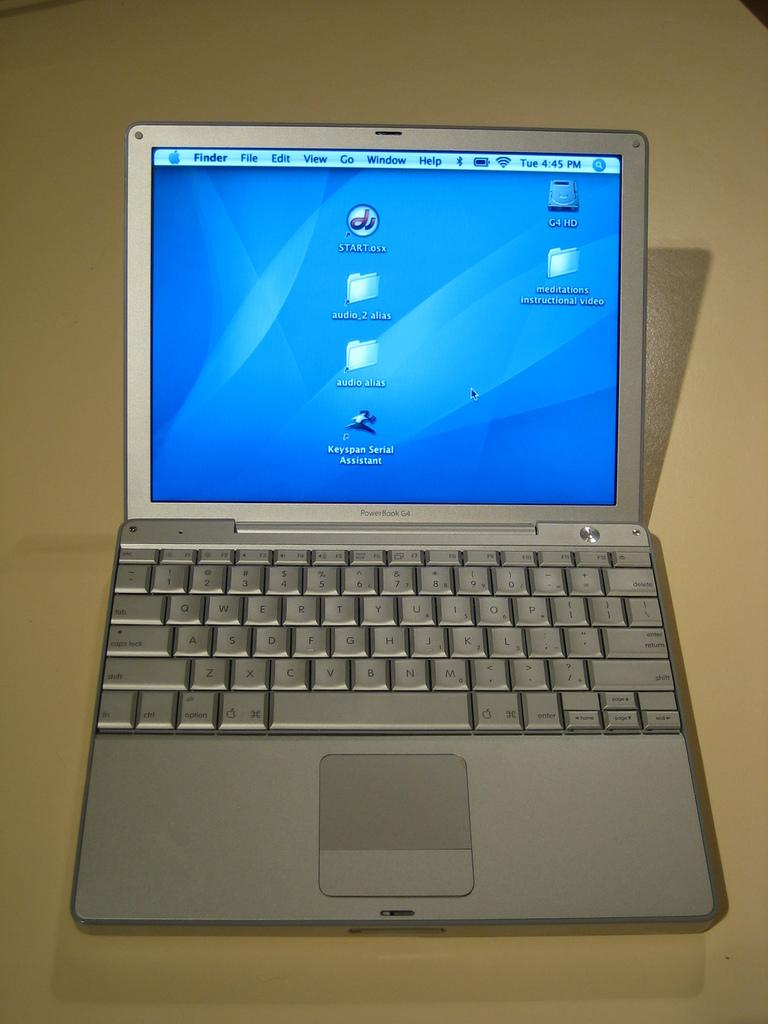Provide a one-sentence caption for the provided image. Black lettering on a small laptop identifies it as a PowerBook G4. 